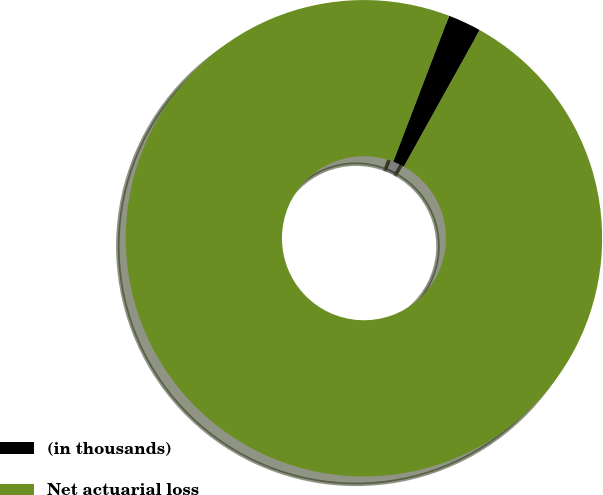<chart> <loc_0><loc_0><loc_500><loc_500><pie_chart><fcel>(in thousands)<fcel>Net actuarial loss<nl><fcel>2.26%<fcel>97.74%<nl></chart> 